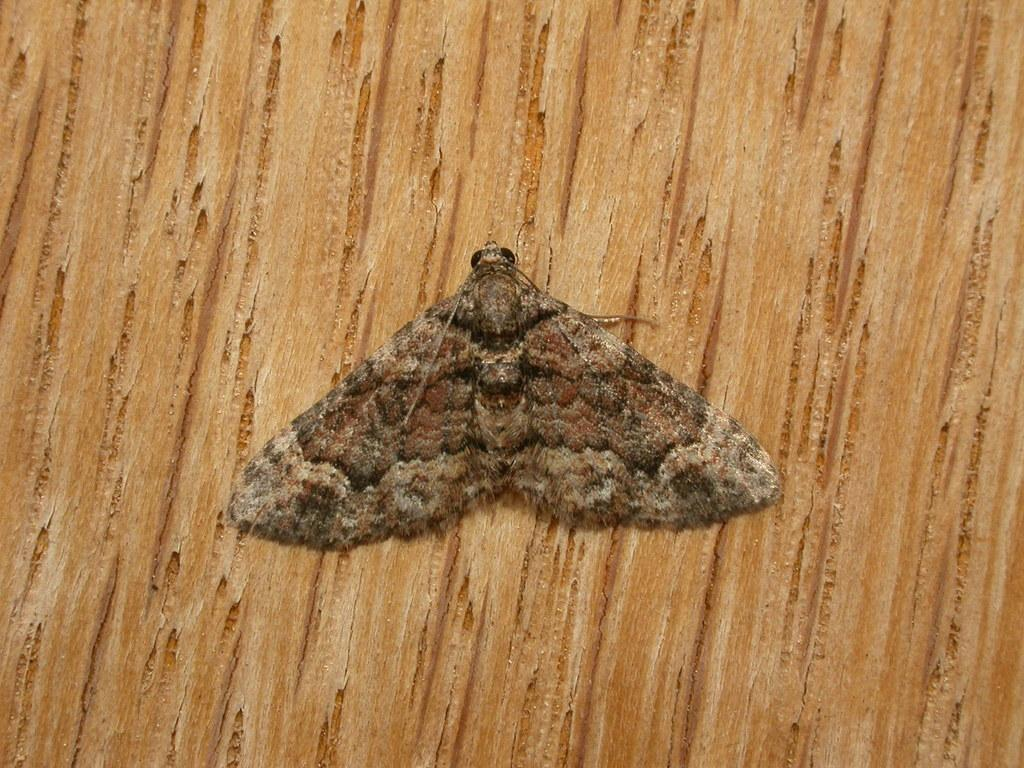What is the main object in the image? There is a wooden plank in the image. What is on the wooden plank? There is a moth on the wooden plank. Can you describe the moth's physical features? The moth has wings and legs. What type of argument is the moth having with the beef in the image? There is no beef present in the image, and therefore no argument can be observed. 